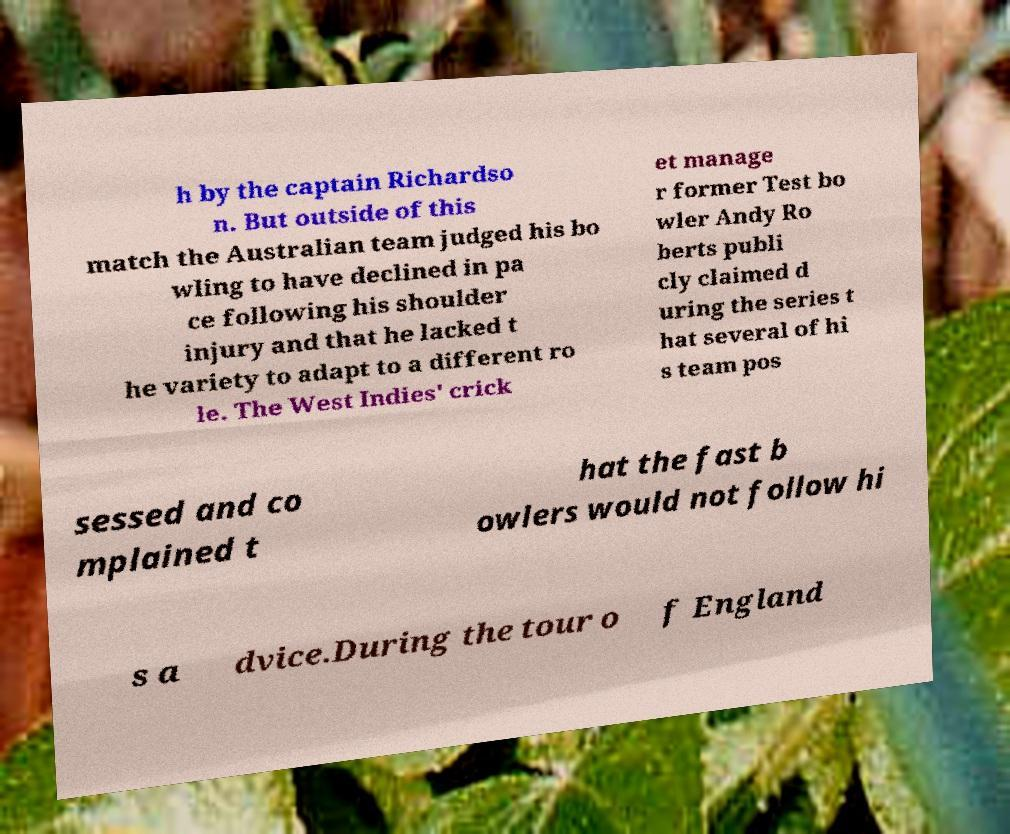I need the written content from this picture converted into text. Can you do that? h by the captain Richardso n. But outside of this match the Australian team judged his bo wling to have declined in pa ce following his shoulder injury and that he lacked t he variety to adapt to a different ro le. The West Indies' crick et manage r former Test bo wler Andy Ro berts publi cly claimed d uring the series t hat several of hi s team pos sessed and co mplained t hat the fast b owlers would not follow hi s a dvice.During the tour o f England 